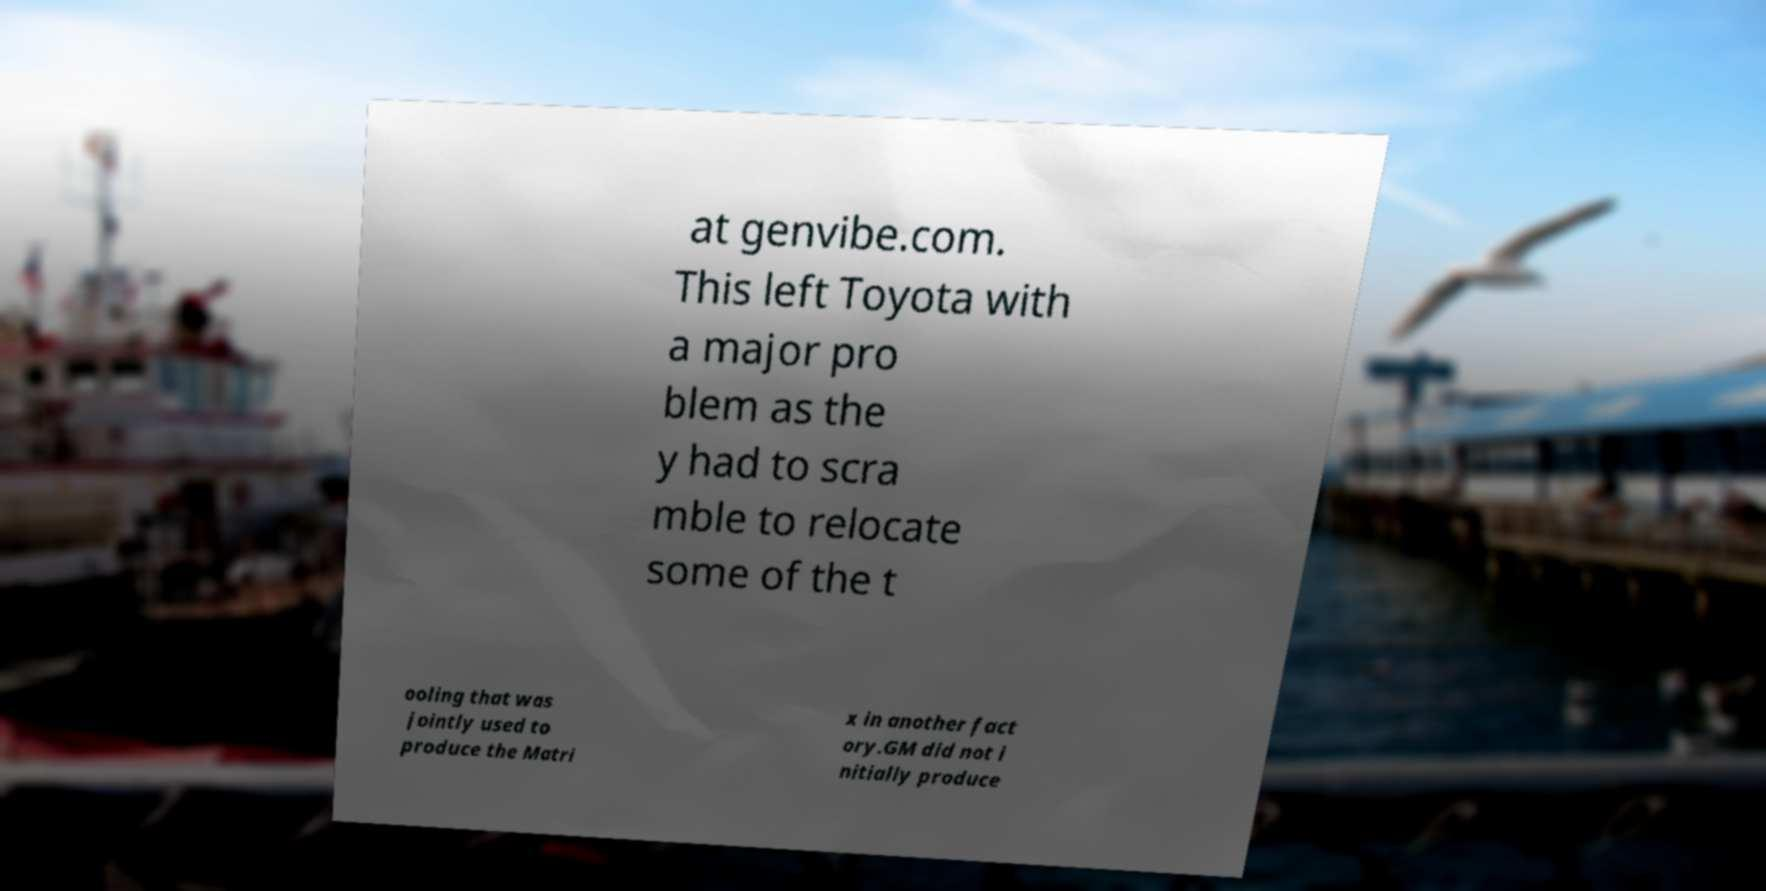Could you assist in decoding the text presented in this image and type it out clearly? at genvibe.com. This left Toyota with a major pro blem as the y had to scra mble to relocate some of the t ooling that was jointly used to produce the Matri x in another fact ory.GM did not i nitially produce 